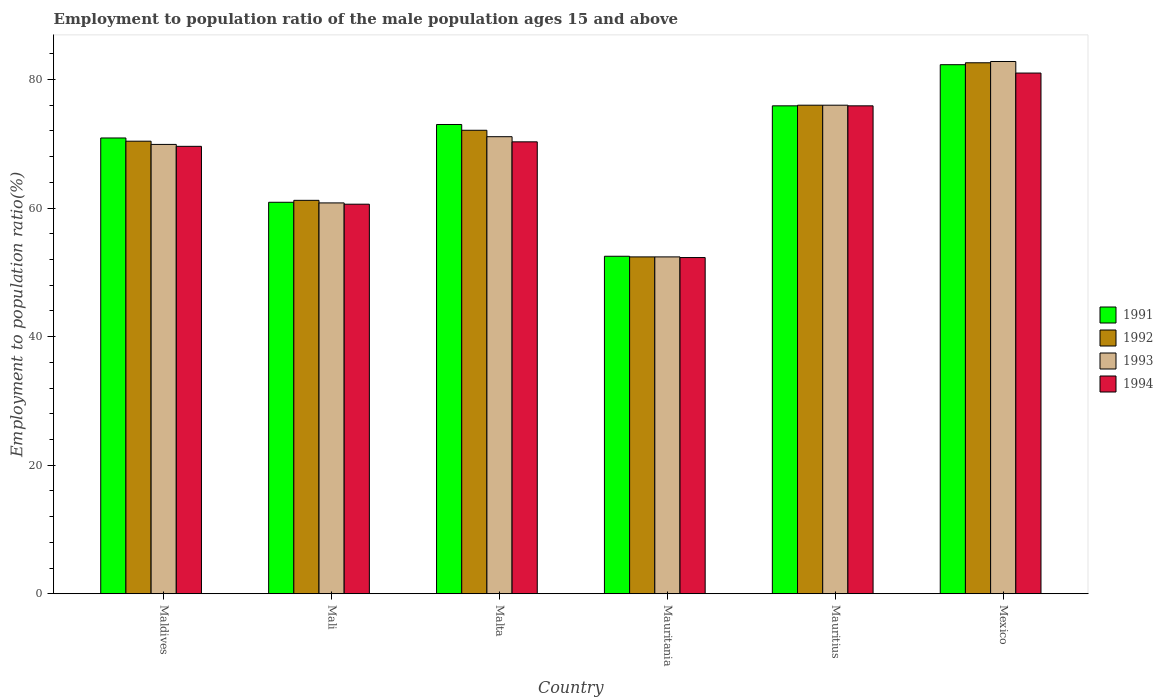How many bars are there on the 6th tick from the left?
Your answer should be compact. 4. How many bars are there on the 3rd tick from the right?
Provide a succinct answer. 4. What is the label of the 6th group of bars from the left?
Provide a short and direct response. Mexico. What is the employment to population ratio in 1991 in Mauritius?
Give a very brief answer. 75.9. Across all countries, what is the maximum employment to population ratio in 1992?
Offer a very short reply. 82.6. Across all countries, what is the minimum employment to population ratio in 1993?
Provide a succinct answer. 52.4. In which country was the employment to population ratio in 1993 maximum?
Make the answer very short. Mexico. In which country was the employment to population ratio in 1992 minimum?
Offer a terse response. Mauritania. What is the total employment to population ratio in 1991 in the graph?
Offer a terse response. 415.5. What is the difference between the employment to population ratio in 1994 in Malta and that in Mexico?
Ensure brevity in your answer.  -10.7. What is the difference between the employment to population ratio in 1994 in Mauritania and the employment to population ratio in 1992 in Mexico?
Offer a terse response. -30.3. What is the average employment to population ratio in 1992 per country?
Offer a very short reply. 69.12. What is the difference between the employment to population ratio of/in 1994 and employment to population ratio of/in 1991 in Malta?
Your answer should be compact. -2.7. In how many countries, is the employment to population ratio in 1991 greater than 32 %?
Offer a very short reply. 6. What is the ratio of the employment to population ratio in 1991 in Mali to that in Mauritius?
Make the answer very short. 0.8. Is the employment to population ratio in 1994 in Maldives less than that in Mexico?
Provide a succinct answer. Yes. What is the difference between the highest and the second highest employment to population ratio in 1993?
Ensure brevity in your answer.  6.8. What is the difference between the highest and the lowest employment to population ratio in 1993?
Keep it short and to the point. 30.4. Is it the case that in every country, the sum of the employment to population ratio in 1991 and employment to population ratio in 1993 is greater than the sum of employment to population ratio in 1992 and employment to population ratio in 1994?
Give a very brief answer. No. What does the 1st bar from the left in Mauritius represents?
Ensure brevity in your answer.  1991. What does the 4th bar from the right in Mauritius represents?
Your answer should be very brief. 1991. Is it the case that in every country, the sum of the employment to population ratio in 1991 and employment to population ratio in 1992 is greater than the employment to population ratio in 1993?
Offer a terse response. Yes. Are all the bars in the graph horizontal?
Provide a succinct answer. No. Are the values on the major ticks of Y-axis written in scientific E-notation?
Offer a terse response. No. Where does the legend appear in the graph?
Your response must be concise. Center right. How many legend labels are there?
Keep it short and to the point. 4. What is the title of the graph?
Keep it short and to the point. Employment to population ratio of the male population ages 15 and above. What is the label or title of the X-axis?
Provide a short and direct response. Country. What is the label or title of the Y-axis?
Your answer should be very brief. Employment to population ratio(%). What is the Employment to population ratio(%) of 1991 in Maldives?
Make the answer very short. 70.9. What is the Employment to population ratio(%) of 1992 in Maldives?
Your response must be concise. 70.4. What is the Employment to population ratio(%) in 1993 in Maldives?
Ensure brevity in your answer.  69.9. What is the Employment to population ratio(%) of 1994 in Maldives?
Keep it short and to the point. 69.6. What is the Employment to population ratio(%) in 1991 in Mali?
Keep it short and to the point. 60.9. What is the Employment to population ratio(%) of 1992 in Mali?
Provide a succinct answer. 61.2. What is the Employment to population ratio(%) of 1993 in Mali?
Your answer should be very brief. 60.8. What is the Employment to population ratio(%) of 1994 in Mali?
Give a very brief answer. 60.6. What is the Employment to population ratio(%) of 1991 in Malta?
Offer a terse response. 73. What is the Employment to population ratio(%) of 1992 in Malta?
Make the answer very short. 72.1. What is the Employment to population ratio(%) of 1993 in Malta?
Make the answer very short. 71.1. What is the Employment to population ratio(%) of 1994 in Malta?
Your answer should be very brief. 70.3. What is the Employment to population ratio(%) of 1991 in Mauritania?
Make the answer very short. 52.5. What is the Employment to population ratio(%) of 1992 in Mauritania?
Ensure brevity in your answer.  52.4. What is the Employment to population ratio(%) of 1993 in Mauritania?
Offer a very short reply. 52.4. What is the Employment to population ratio(%) of 1994 in Mauritania?
Provide a succinct answer. 52.3. What is the Employment to population ratio(%) in 1991 in Mauritius?
Ensure brevity in your answer.  75.9. What is the Employment to population ratio(%) in 1992 in Mauritius?
Give a very brief answer. 76. What is the Employment to population ratio(%) of 1994 in Mauritius?
Offer a very short reply. 75.9. What is the Employment to population ratio(%) of 1991 in Mexico?
Your answer should be very brief. 82.3. What is the Employment to population ratio(%) in 1992 in Mexico?
Provide a short and direct response. 82.6. What is the Employment to population ratio(%) in 1993 in Mexico?
Make the answer very short. 82.8. Across all countries, what is the maximum Employment to population ratio(%) of 1991?
Offer a terse response. 82.3. Across all countries, what is the maximum Employment to population ratio(%) of 1992?
Give a very brief answer. 82.6. Across all countries, what is the maximum Employment to population ratio(%) of 1993?
Your answer should be compact. 82.8. Across all countries, what is the maximum Employment to population ratio(%) of 1994?
Provide a succinct answer. 81. Across all countries, what is the minimum Employment to population ratio(%) in 1991?
Your answer should be compact. 52.5. Across all countries, what is the minimum Employment to population ratio(%) of 1992?
Make the answer very short. 52.4. Across all countries, what is the minimum Employment to population ratio(%) of 1993?
Offer a very short reply. 52.4. Across all countries, what is the minimum Employment to population ratio(%) of 1994?
Give a very brief answer. 52.3. What is the total Employment to population ratio(%) in 1991 in the graph?
Provide a short and direct response. 415.5. What is the total Employment to population ratio(%) in 1992 in the graph?
Keep it short and to the point. 414.7. What is the total Employment to population ratio(%) of 1993 in the graph?
Keep it short and to the point. 413. What is the total Employment to population ratio(%) in 1994 in the graph?
Provide a short and direct response. 409.7. What is the difference between the Employment to population ratio(%) in 1993 in Maldives and that in Mali?
Offer a terse response. 9.1. What is the difference between the Employment to population ratio(%) of 1994 in Maldives and that in Mali?
Give a very brief answer. 9. What is the difference between the Employment to population ratio(%) of 1991 in Maldives and that in Malta?
Offer a terse response. -2.1. What is the difference between the Employment to population ratio(%) of 1991 in Maldives and that in Mauritius?
Your answer should be compact. -5. What is the difference between the Employment to population ratio(%) in 1991 in Maldives and that in Mexico?
Ensure brevity in your answer.  -11.4. What is the difference between the Employment to population ratio(%) of 1992 in Maldives and that in Mexico?
Your response must be concise. -12.2. What is the difference between the Employment to population ratio(%) of 1992 in Mali and that in Malta?
Offer a terse response. -10.9. What is the difference between the Employment to population ratio(%) in 1994 in Mali and that in Malta?
Give a very brief answer. -9.7. What is the difference between the Employment to population ratio(%) in 1991 in Mali and that in Mauritania?
Make the answer very short. 8.4. What is the difference between the Employment to population ratio(%) in 1994 in Mali and that in Mauritania?
Your answer should be very brief. 8.3. What is the difference between the Employment to population ratio(%) of 1991 in Mali and that in Mauritius?
Keep it short and to the point. -15. What is the difference between the Employment to population ratio(%) in 1992 in Mali and that in Mauritius?
Keep it short and to the point. -14.8. What is the difference between the Employment to population ratio(%) in 1993 in Mali and that in Mauritius?
Give a very brief answer. -15.2. What is the difference between the Employment to population ratio(%) of 1994 in Mali and that in Mauritius?
Give a very brief answer. -15.3. What is the difference between the Employment to population ratio(%) of 1991 in Mali and that in Mexico?
Your response must be concise. -21.4. What is the difference between the Employment to population ratio(%) of 1992 in Mali and that in Mexico?
Keep it short and to the point. -21.4. What is the difference between the Employment to population ratio(%) of 1994 in Mali and that in Mexico?
Your answer should be very brief. -20.4. What is the difference between the Employment to population ratio(%) of 1993 in Malta and that in Mauritania?
Offer a terse response. 18.7. What is the difference between the Employment to population ratio(%) of 1992 in Malta and that in Mexico?
Your answer should be very brief. -10.5. What is the difference between the Employment to population ratio(%) of 1993 in Malta and that in Mexico?
Offer a very short reply. -11.7. What is the difference between the Employment to population ratio(%) of 1994 in Malta and that in Mexico?
Your answer should be compact. -10.7. What is the difference between the Employment to population ratio(%) in 1991 in Mauritania and that in Mauritius?
Make the answer very short. -23.4. What is the difference between the Employment to population ratio(%) of 1992 in Mauritania and that in Mauritius?
Keep it short and to the point. -23.6. What is the difference between the Employment to population ratio(%) of 1993 in Mauritania and that in Mauritius?
Keep it short and to the point. -23.6. What is the difference between the Employment to population ratio(%) of 1994 in Mauritania and that in Mauritius?
Make the answer very short. -23.6. What is the difference between the Employment to population ratio(%) in 1991 in Mauritania and that in Mexico?
Your answer should be compact. -29.8. What is the difference between the Employment to population ratio(%) of 1992 in Mauritania and that in Mexico?
Keep it short and to the point. -30.2. What is the difference between the Employment to population ratio(%) of 1993 in Mauritania and that in Mexico?
Keep it short and to the point. -30.4. What is the difference between the Employment to population ratio(%) of 1994 in Mauritania and that in Mexico?
Your answer should be very brief. -28.7. What is the difference between the Employment to population ratio(%) of 1993 in Mauritius and that in Mexico?
Your response must be concise. -6.8. What is the difference between the Employment to population ratio(%) of 1994 in Mauritius and that in Mexico?
Offer a terse response. -5.1. What is the difference between the Employment to population ratio(%) of 1991 in Maldives and the Employment to population ratio(%) of 1994 in Mali?
Ensure brevity in your answer.  10.3. What is the difference between the Employment to population ratio(%) of 1992 in Maldives and the Employment to population ratio(%) of 1993 in Malta?
Make the answer very short. -0.7. What is the difference between the Employment to population ratio(%) in 1993 in Maldives and the Employment to population ratio(%) in 1994 in Malta?
Provide a short and direct response. -0.4. What is the difference between the Employment to population ratio(%) in 1991 in Maldives and the Employment to population ratio(%) in 1994 in Mauritania?
Offer a terse response. 18.6. What is the difference between the Employment to population ratio(%) of 1992 in Maldives and the Employment to population ratio(%) of 1994 in Mauritania?
Ensure brevity in your answer.  18.1. What is the difference between the Employment to population ratio(%) in 1993 in Maldives and the Employment to population ratio(%) in 1994 in Mauritania?
Give a very brief answer. 17.6. What is the difference between the Employment to population ratio(%) in 1993 in Maldives and the Employment to population ratio(%) in 1994 in Mauritius?
Provide a short and direct response. -6. What is the difference between the Employment to population ratio(%) in 1991 in Maldives and the Employment to population ratio(%) in 1992 in Mexico?
Ensure brevity in your answer.  -11.7. What is the difference between the Employment to population ratio(%) in 1992 in Maldives and the Employment to population ratio(%) in 1993 in Mexico?
Provide a short and direct response. -12.4. What is the difference between the Employment to population ratio(%) of 1991 in Mali and the Employment to population ratio(%) of 1992 in Malta?
Your answer should be very brief. -11.2. What is the difference between the Employment to population ratio(%) of 1992 in Mali and the Employment to population ratio(%) of 1993 in Malta?
Make the answer very short. -9.9. What is the difference between the Employment to population ratio(%) in 1993 in Mali and the Employment to population ratio(%) in 1994 in Malta?
Provide a short and direct response. -9.5. What is the difference between the Employment to population ratio(%) of 1992 in Mali and the Employment to population ratio(%) of 1994 in Mauritania?
Provide a succinct answer. 8.9. What is the difference between the Employment to population ratio(%) in 1991 in Mali and the Employment to population ratio(%) in 1992 in Mauritius?
Your answer should be very brief. -15.1. What is the difference between the Employment to population ratio(%) of 1991 in Mali and the Employment to population ratio(%) of 1993 in Mauritius?
Keep it short and to the point. -15.1. What is the difference between the Employment to population ratio(%) of 1991 in Mali and the Employment to population ratio(%) of 1994 in Mauritius?
Ensure brevity in your answer.  -15. What is the difference between the Employment to population ratio(%) in 1992 in Mali and the Employment to population ratio(%) in 1993 in Mauritius?
Make the answer very short. -14.8. What is the difference between the Employment to population ratio(%) of 1992 in Mali and the Employment to population ratio(%) of 1994 in Mauritius?
Your answer should be very brief. -14.7. What is the difference between the Employment to population ratio(%) in 1993 in Mali and the Employment to population ratio(%) in 1994 in Mauritius?
Your response must be concise. -15.1. What is the difference between the Employment to population ratio(%) of 1991 in Mali and the Employment to population ratio(%) of 1992 in Mexico?
Your answer should be very brief. -21.7. What is the difference between the Employment to population ratio(%) of 1991 in Mali and the Employment to population ratio(%) of 1993 in Mexico?
Keep it short and to the point. -21.9. What is the difference between the Employment to population ratio(%) in 1991 in Mali and the Employment to population ratio(%) in 1994 in Mexico?
Provide a short and direct response. -20.1. What is the difference between the Employment to population ratio(%) in 1992 in Mali and the Employment to population ratio(%) in 1993 in Mexico?
Provide a succinct answer. -21.6. What is the difference between the Employment to population ratio(%) in 1992 in Mali and the Employment to population ratio(%) in 1994 in Mexico?
Give a very brief answer. -19.8. What is the difference between the Employment to population ratio(%) of 1993 in Mali and the Employment to population ratio(%) of 1994 in Mexico?
Your answer should be very brief. -20.2. What is the difference between the Employment to population ratio(%) of 1991 in Malta and the Employment to population ratio(%) of 1992 in Mauritania?
Your response must be concise. 20.6. What is the difference between the Employment to population ratio(%) of 1991 in Malta and the Employment to population ratio(%) of 1993 in Mauritania?
Make the answer very short. 20.6. What is the difference between the Employment to population ratio(%) of 1991 in Malta and the Employment to population ratio(%) of 1994 in Mauritania?
Your response must be concise. 20.7. What is the difference between the Employment to population ratio(%) in 1992 in Malta and the Employment to population ratio(%) in 1993 in Mauritania?
Your answer should be very brief. 19.7. What is the difference between the Employment to population ratio(%) in 1992 in Malta and the Employment to population ratio(%) in 1994 in Mauritania?
Ensure brevity in your answer.  19.8. What is the difference between the Employment to population ratio(%) in 1993 in Malta and the Employment to population ratio(%) in 1994 in Mauritania?
Ensure brevity in your answer.  18.8. What is the difference between the Employment to population ratio(%) in 1991 in Malta and the Employment to population ratio(%) in 1994 in Mauritius?
Keep it short and to the point. -2.9. What is the difference between the Employment to population ratio(%) in 1992 in Malta and the Employment to population ratio(%) in 1993 in Mauritius?
Your response must be concise. -3.9. What is the difference between the Employment to population ratio(%) in 1992 in Malta and the Employment to population ratio(%) in 1994 in Mauritius?
Offer a terse response. -3.8. What is the difference between the Employment to population ratio(%) in 1993 in Malta and the Employment to population ratio(%) in 1994 in Mauritius?
Give a very brief answer. -4.8. What is the difference between the Employment to population ratio(%) of 1991 in Malta and the Employment to population ratio(%) of 1992 in Mexico?
Ensure brevity in your answer.  -9.6. What is the difference between the Employment to population ratio(%) in 1991 in Malta and the Employment to population ratio(%) in 1994 in Mexico?
Your answer should be very brief. -8. What is the difference between the Employment to population ratio(%) in 1992 in Malta and the Employment to population ratio(%) in 1993 in Mexico?
Make the answer very short. -10.7. What is the difference between the Employment to population ratio(%) in 1992 in Malta and the Employment to population ratio(%) in 1994 in Mexico?
Your answer should be compact. -8.9. What is the difference between the Employment to population ratio(%) in 1991 in Mauritania and the Employment to population ratio(%) in 1992 in Mauritius?
Give a very brief answer. -23.5. What is the difference between the Employment to population ratio(%) of 1991 in Mauritania and the Employment to population ratio(%) of 1993 in Mauritius?
Ensure brevity in your answer.  -23.5. What is the difference between the Employment to population ratio(%) in 1991 in Mauritania and the Employment to population ratio(%) in 1994 in Mauritius?
Ensure brevity in your answer.  -23.4. What is the difference between the Employment to population ratio(%) in 1992 in Mauritania and the Employment to population ratio(%) in 1993 in Mauritius?
Your answer should be compact. -23.6. What is the difference between the Employment to population ratio(%) in 1992 in Mauritania and the Employment to population ratio(%) in 1994 in Mauritius?
Offer a very short reply. -23.5. What is the difference between the Employment to population ratio(%) in 1993 in Mauritania and the Employment to population ratio(%) in 1994 in Mauritius?
Offer a very short reply. -23.5. What is the difference between the Employment to population ratio(%) of 1991 in Mauritania and the Employment to population ratio(%) of 1992 in Mexico?
Provide a short and direct response. -30.1. What is the difference between the Employment to population ratio(%) of 1991 in Mauritania and the Employment to population ratio(%) of 1993 in Mexico?
Your answer should be very brief. -30.3. What is the difference between the Employment to population ratio(%) in 1991 in Mauritania and the Employment to population ratio(%) in 1994 in Mexico?
Keep it short and to the point. -28.5. What is the difference between the Employment to population ratio(%) of 1992 in Mauritania and the Employment to population ratio(%) of 1993 in Mexico?
Your answer should be very brief. -30.4. What is the difference between the Employment to population ratio(%) in 1992 in Mauritania and the Employment to population ratio(%) in 1994 in Mexico?
Provide a succinct answer. -28.6. What is the difference between the Employment to population ratio(%) in 1993 in Mauritania and the Employment to population ratio(%) in 1994 in Mexico?
Your response must be concise. -28.6. What is the difference between the Employment to population ratio(%) of 1991 in Mauritius and the Employment to population ratio(%) of 1993 in Mexico?
Offer a very short reply. -6.9. What is the difference between the Employment to population ratio(%) of 1991 in Mauritius and the Employment to population ratio(%) of 1994 in Mexico?
Your answer should be very brief. -5.1. What is the difference between the Employment to population ratio(%) in 1992 in Mauritius and the Employment to population ratio(%) in 1994 in Mexico?
Give a very brief answer. -5. What is the difference between the Employment to population ratio(%) of 1993 in Mauritius and the Employment to population ratio(%) of 1994 in Mexico?
Provide a succinct answer. -5. What is the average Employment to population ratio(%) in 1991 per country?
Your answer should be very brief. 69.25. What is the average Employment to population ratio(%) in 1992 per country?
Your response must be concise. 69.12. What is the average Employment to population ratio(%) of 1993 per country?
Provide a short and direct response. 68.83. What is the average Employment to population ratio(%) in 1994 per country?
Offer a very short reply. 68.28. What is the difference between the Employment to population ratio(%) of 1992 and Employment to population ratio(%) of 1993 in Maldives?
Provide a succinct answer. 0.5. What is the difference between the Employment to population ratio(%) in 1993 and Employment to population ratio(%) in 1994 in Maldives?
Offer a terse response. 0.3. What is the difference between the Employment to population ratio(%) of 1991 and Employment to population ratio(%) of 1992 in Mali?
Ensure brevity in your answer.  -0.3. What is the difference between the Employment to population ratio(%) in 1992 and Employment to population ratio(%) in 1994 in Mali?
Give a very brief answer. 0.6. What is the difference between the Employment to population ratio(%) in 1991 and Employment to population ratio(%) in 1992 in Malta?
Provide a succinct answer. 0.9. What is the difference between the Employment to population ratio(%) in 1992 and Employment to population ratio(%) in 1994 in Malta?
Offer a terse response. 1.8. What is the difference between the Employment to population ratio(%) in 1993 and Employment to population ratio(%) in 1994 in Malta?
Offer a terse response. 0.8. What is the difference between the Employment to population ratio(%) in 1991 and Employment to population ratio(%) in 1994 in Mauritania?
Offer a terse response. 0.2. What is the difference between the Employment to population ratio(%) in 1992 and Employment to population ratio(%) in 1993 in Mauritania?
Make the answer very short. 0. What is the difference between the Employment to population ratio(%) of 1993 and Employment to population ratio(%) of 1994 in Mauritania?
Make the answer very short. 0.1. What is the difference between the Employment to population ratio(%) of 1991 and Employment to population ratio(%) of 1993 in Mauritius?
Provide a short and direct response. -0.1. What is the difference between the Employment to population ratio(%) in 1992 and Employment to population ratio(%) in 1993 in Mauritius?
Your response must be concise. 0. What is the difference between the Employment to population ratio(%) of 1993 and Employment to population ratio(%) of 1994 in Mauritius?
Offer a terse response. 0.1. What is the difference between the Employment to population ratio(%) of 1993 and Employment to population ratio(%) of 1994 in Mexico?
Offer a terse response. 1.8. What is the ratio of the Employment to population ratio(%) in 1991 in Maldives to that in Mali?
Your response must be concise. 1.16. What is the ratio of the Employment to population ratio(%) of 1992 in Maldives to that in Mali?
Give a very brief answer. 1.15. What is the ratio of the Employment to population ratio(%) in 1993 in Maldives to that in Mali?
Make the answer very short. 1.15. What is the ratio of the Employment to population ratio(%) of 1994 in Maldives to that in Mali?
Offer a terse response. 1.15. What is the ratio of the Employment to population ratio(%) in 1991 in Maldives to that in Malta?
Offer a terse response. 0.97. What is the ratio of the Employment to population ratio(%) in 1992 in Maldives to that in Malta?
Provide a short and direct response. 0.98. What is the ratio of the Employment to population ratio(%) of 1993 in Maldives to that in Malta?
Make the answer very short. 0.98. What is the ratio of the Employment to population ratio(%) of 1991 in Maldives to that in Mauritania?
Provide a short and direct response. 1.35. What is the ratio of the Employment to population ratio(%) in 1992 in Maldives to that in Mauritania?
Keep it short and to the point. 1.34. What is the ratio of the Employment to population ratio(%) of 1993 in Maldives to that in Mauritania?
Keep it short and to the point. 1.33. What is the ratio of the Employment to population ratio(%) of 1994 in Maldives to that in Mauritania?
Offer a terse response. 1.33. What is the ratio of the Employment to population ratio(%) in 1991 in Maldives to that in Mauritius?
Offer a terse response. 0.93. What is the ratio of the Employment to population ratio(%) of 1992 in Maldives to that in Mauritius?
Ensure brevity in your answer.  0.93. What is the ratio of the Employment to population ratio(%) in 1993 in Maldives to that in Mauritius?
Keep it short and to the point. 0.92. What is the ratio of the Employment to population ratio(%) in 1994 in Maldives to that in Mauritius?
Offer a terse response. 0.92. What is the ratio of the Employment to population ratio(%) of 1991 in Maldives to that in Mexico?
Offer a very short reply. 0.86. What is the ratio of the Employment to population ratio(%) in 1992 in Maldives to that in Mexico?
Make the answer very short. 0.85. What is the ratio of the Employment to population ratio(%) in 1993 in Maldives to that in Mexico?
Your answer should be very brief. 0.84. What is the ratio of the Employment to population ratio(%) of 1994 in Maldives to that in Mexico?
Your answer should be very brief. 0.86. What is the ratio of the Employment to population ratio(%) in 1991 in Mali to that in Malta?
Offer a terse response. 0.83. What is the ratio of the Employment to population ratio(%) in 1992 in Mali to that in Malta?
Provide a short and direct response. 0.85. What is the ratio of the Employment to population ratio(%) of 1993 in Mali to that in Malta?
Give a very brief answer. 0.86. What is the ratio of the Employment to population ratio(%) of 1994 in Mali to that in Malta?
Make the answer very short. 0.86. What is the ratio of the Employment to population ratio(%) in 1991 in Mali to that in Mauritania?
Give a very brief answer. 1.16. What is the ratio of the Employment to population ratio(%) in 1992 in Mali to that in Mauritania?
Provide a short and direct response. 1.17. What is the ratio of the Employment to population ratio(%) in 1993 in Mali to that in Mauritania?
Offer a terse response. 1.16. What is the ratio of the Employment to population ratio(%) of 1994 in Mali to that in Mauritania?
Offer a terse response. 1.16. What is the ratio of the Employment to population ratio(%) of 1991 in Mali to that in Mauritius?
Make the answer very short. 0.8. What is the ratio of the Employment to population ratio(%) of 1992 in Mali to that in Mauritius?
Give a very brief answer. 0.81. What is the ratio of the Employment to population ratio(%) in 1994 in Mali to that in Mauritius?
Your response must be concise. 0.8. What is the ratio of the Employment to population ratio(%) in 1991 in Mali to that in Mexico?
Ensure brevity in your answer.  0.74. What is the ratio of the Employment to population ratio(%) in 1992 in Mali to that in Mexico?
Your response must be concise. 0.74. What is the ratio of the Employment to population ratio(%) of 1993 in Mali to that in Mexico?
Keep it short and to the point. 0.73. What is the ratio of the Employment to population ratio(%) in 1994 in Mali to that in Mexico?
Offer a terse response. 0.75. What is the ratio of the Employment to population ratio(%) of 1991 in Malta to that in Mauritania?
Offer a very short reply. 1.39. What is the ratio of the Employment to population ratio(%) of 1992 in Malta to that in Mauritania?
Your answer should be very brief. 1.38. What is the ratio of the Employment to population ratio(%) of 1993 in Malta to that in Mauritania?
Ensure brevity in your answer.  1.36. What is the ratio of the Employment to population ratio(%) of 1994 in Malta to that in Mauritania?
Your answer should be very brief. 1.34. What is the ratio of the Employment to population ratio(%) of 1991 in Malta to that in Mauritius?
Make the answer very short. 0.96. What is the ratio of the Employment to population ratio(%) of 1992 in Malta to that in Mauritius?
Provide a short and direct response. 0.95. What is the ratio of the Employment to population ratio(%) of 1993 in Malta to that in Mauritius?
Provide a succinct answer. 0.94. What is the ratio of the Employment to population ratio(%) of 1994 in Malta to that in Mauritius?
Provide a short and direct response. 0.93. What is the ratio of the Employment to population ratio(%) of 1991 in Malta to that in Mexico?
Offer a terse response. 0.89. What is the ratio of the Employment to population ratio(%) of 1992 in Malta to that in Mexico?
Keep it short and to the point. 0.87. What is the ratio of the Employment to population ratio(%) in 1993 in Malta to that in Mexico?
Offer a terse response. 0.86. What is the ratio of the Employment to population ratio(%) in 1994 in Malta to that in Mexico?
Offer a very short reply. 0.87. What is the ratio of the Employment to population ratio(%) of 1991 in Mauritania to that in Mauritius?
Provide a short and direct response. 0.69. What is the ratio of the Employment to population ratio(%) in 1992 in Mauritania to that in Mauritius?
Your response must be concise. 0.69. What is the ratio of the Employment to population ratio(%) of 1993 in Mauritania to that in Mauritius?
Keep it short and to the point. 0.69. What is the ratio of the Employment to population ratio(%) in 1994 in Mauritania to that in Mauritius?
Ensure brevity in your answer.  0.69. What is the ratio of the Employment to population ratio(%) of 1991 in Mauritania to that in Mexico?
Provide a succinct answer. 0.64. What is the ratio of the Employment to population ratio(%) in 1992 in Mauritania to that in Mexico?
Keep it short and to the point. 0.63. What is the ratio of the Employment to population ratio(%) in 1993 in Mauritania to that in Mexico?
Give a very brief answer. 0.63. What is the ratio of the Employment to population ratio(%) in 1994 in Mauritania to that in Mexico?
Your answer should be compact. 0.65. What is the ratio of the Employment to population ratio(%) of 1991 in Mauritius to that in Mexico?
Ensure brevity in your answer.  0.92. What is the ratio of the Employment to population ratio(%) of 1992 in Mauritius to that in Mexico?
Your answer should be compact. 0.92. What is the ratio of the Employment to population ratio(%) in 1993 in Mauritius to that in Mexico?
Provide a succinct answer. 0.92. What is the ratio of the Employment to population ratio(%) in 1994 in Mauritius to that in Mexico?
Provide a succinct answer. 0.94. What is the difference between the highest and the second highest Employment to population ratio(%) in 1991?
Your response must be concise. 6.4. What is the difference between the highest and the lowest Employment to population ratio(%) in 1991?
Provide a succinct answer. 29.8. What is the difference between the highest and the lowest Employment to population ratio(%) of 1992?
Your answer should be compact. 30.2. What is the difference between the highest and the lowest Employment to population ratio(%) of 1993?
Give a very brief answer. 30.4. What is the difference between the highest and the lowest Employment to population ratio(%) of 1994?
Make the answer very short. 28.7. 